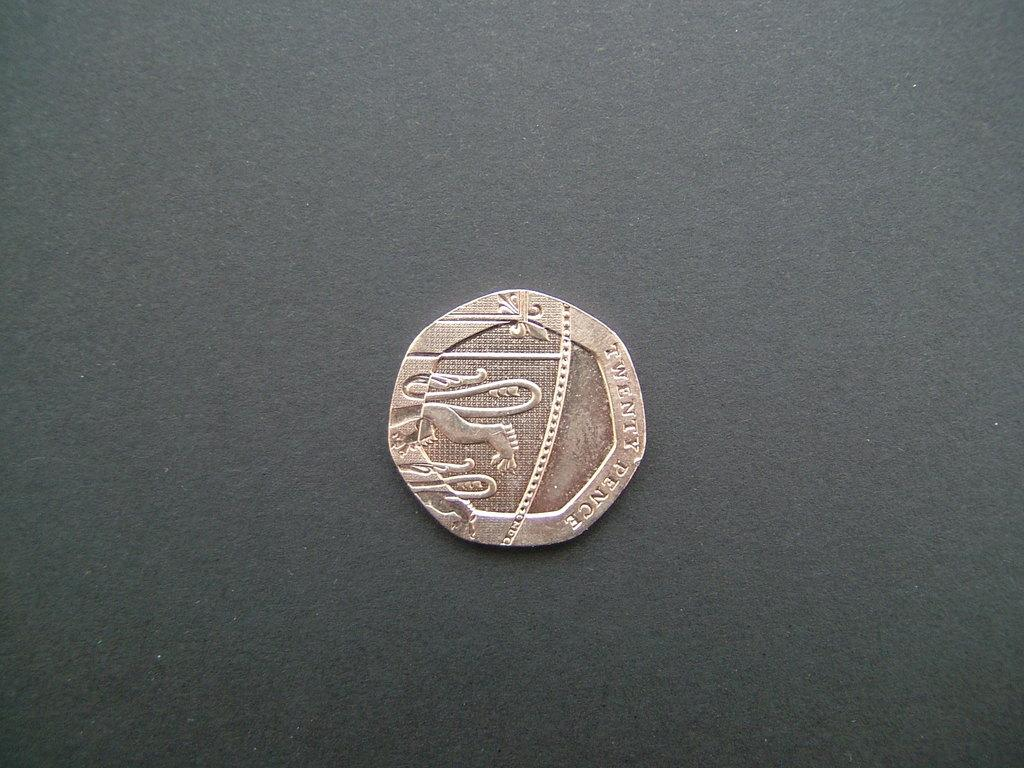<image>
Offer a succinct explanation of the picture presented. The twenty Pence coin has the back legs of what appears to be a lion. 